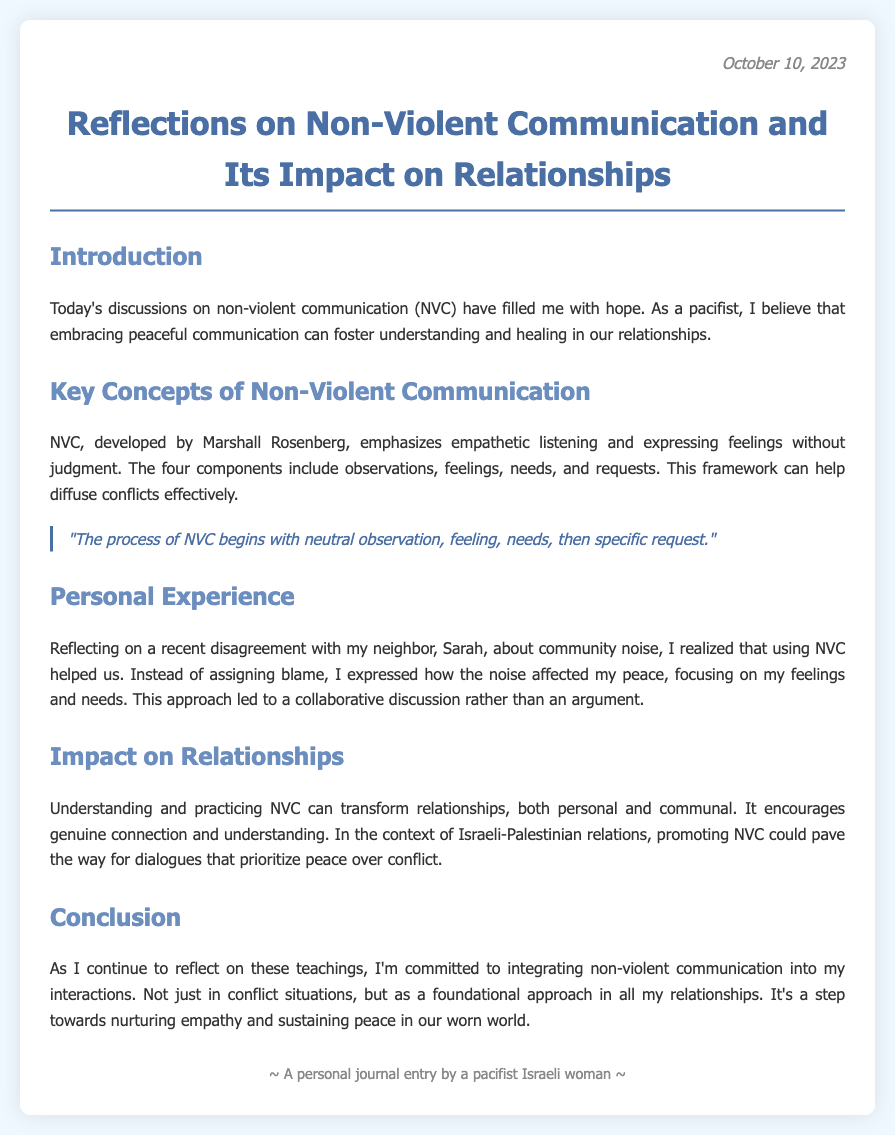What is the date of the journal entry? The date is mentioned at the top of the document under the date section.
Answer: October 10, 2023 Who developed Non-Violent Communication? The document specifically mentions the founder of Non-Violent Communication.
Answer: Marshall Rosenberg What is one of the key components of NVC? The document lists components of NVC in the second section.
Answer: observations What personal experience is shared in the journal? The document reflects on a specific disagreement involving the author's neighbor.
Answer: disagreement with my neighbor, Sarah What does NVC encourage in relationships? The document discusses the impact of NVC on relationships and what it promotes.
Answer: genuine connection How does the author feel about the discussions on NVC? The author expresses their feelings towards the discussions in the introduction.
Answer: filled with hope What is the overall theme of the journal entry? The conclusion of the document provides insight into the theme of the reflections.
Answer: integrating non-violent communication In which context does the author reflect on promoting NVC? The document highlights a specific conflict context relevant to the author's reflections.
Answer: Israeli-Palestinian relations 